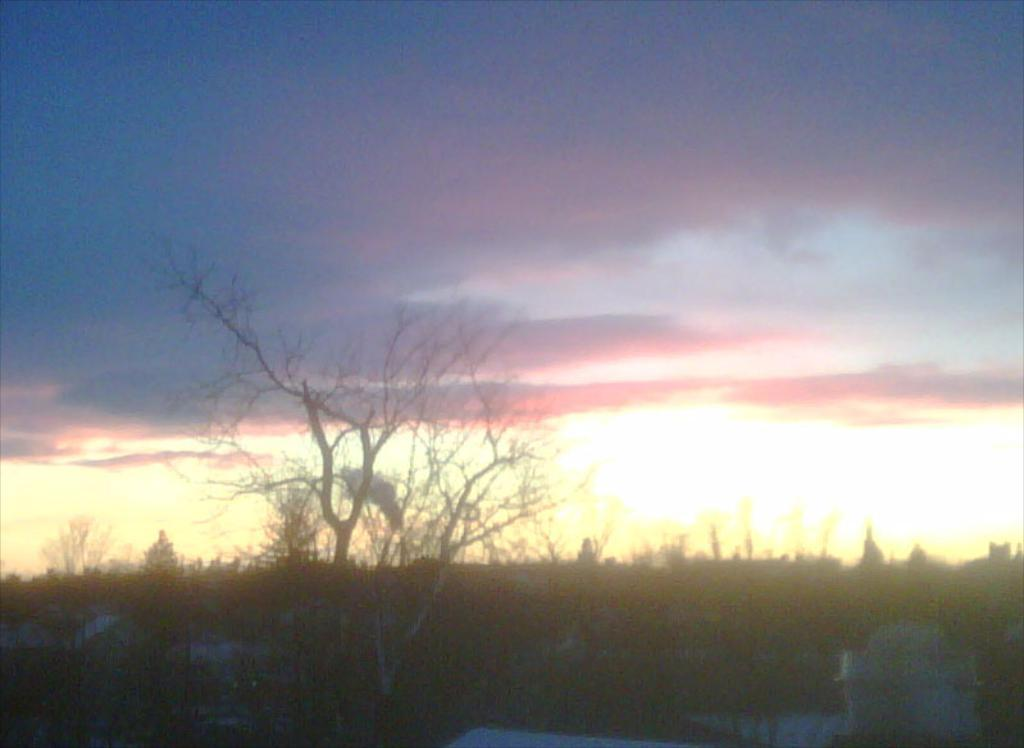What type of vegetation can be seen in the image? There are trees in the image. What is visible in the background of the image? The sky is visible in the background of the image. What can be observed in the sky? Clouds are present in the sky. What type of quartz can be seen in the image? There is no quartz present in the image. Can you hear a whistle in the image? There is no sound, including a whistle, present in the image. 